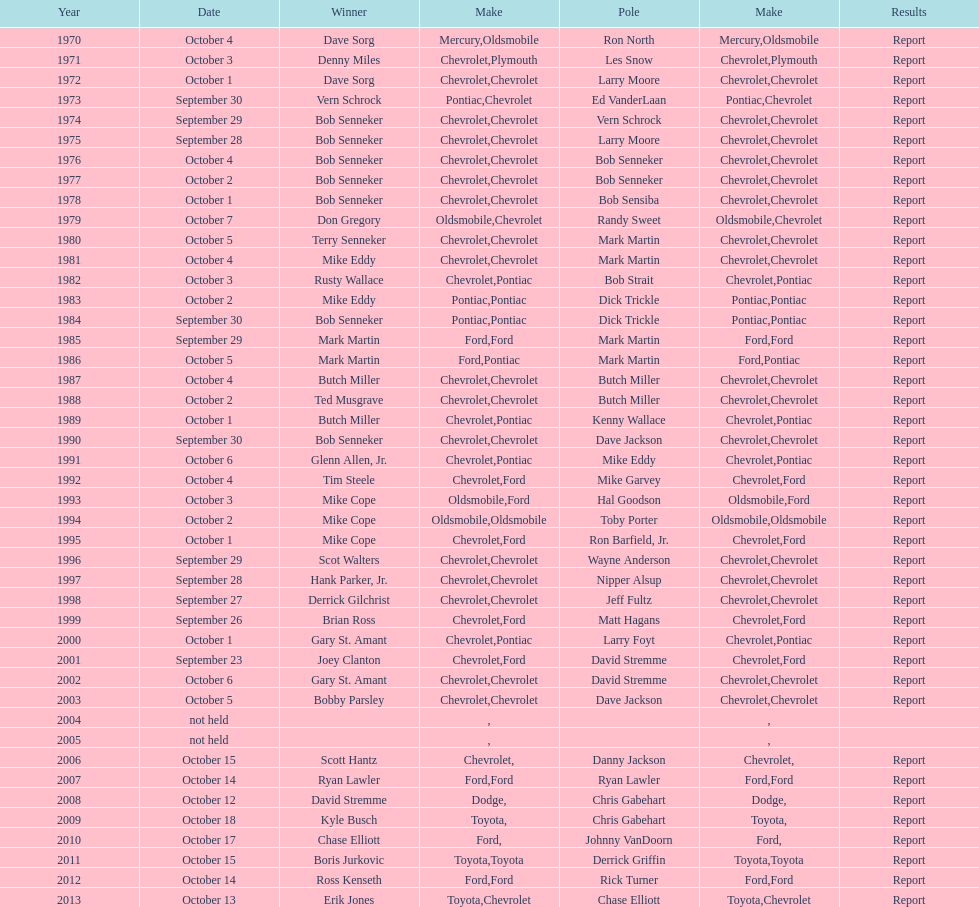Write the full table. {'header': ['Year', 'Date', 'Winner', 'Make', 'Pole', 'Make', 'Results'], 'rows': [['1970', 'October 4', 'Dave Sorg', 'Mercury', 'Ron North', 'Oldsmobile', 'Report'], ['1971', 'October 3', 'Denny Miles', 'Chevrolet', 'Les Snow', 'Plymouth', 'Report'], ['1972', 'October 1', 'Dave Sorg', 'Chevrolet', 'Larry Moore', 'Chevrolet', 'Report'], ['1973', 'September 30', 'Vern Schrock', 'Pontiac', 'Ed VanderLaan', 'Chevrolet', 'Report'], ['1974', 'September 29', 'Bob Senneker', 'Chevrolet', 'Vern Schrock', 'Chevrolet', 'Report'], ['1975', 'September 28', 'Bob Senneker', 'Chevrolet', 'Larry Moore', 'Chevrolet', 'Report'], ['1976', 'October 4', 'Bob Senneker', 'Chevrolet', 'Bob Senneker', 'Chevrolet', 'Report'], ['1977', 'October 2', 'Bob Senneker', 'Chevrolet', 'Bob Senneker', 'Chevrolet', 'Report'], ['1978', 'October 1', 'Bob Senneker', 'Chevrolet', 'Bob Sensiba', 'Chevrolet', 'Report'], ['1979', 'October 7', 'Don Gregory', 'Oldsmobile', 'Randy Sweet', 'Chevrolet', 'Report'], ['1980', 'October 5', 'Terry Senneker', 'Chevrolet', 'Mark Martin', 'Chevrolet', 'Report'], ['1981', 'October 4', 'Mike Eddy', 'Chevrolet', 'Mark Martin', 'Chevrolet', 'Report'], ['1982', 'October 3', 'Rusty Wallace', 'Chevrolet', 'Bob Strait', 'Pontiac', 'Report'], ['1983', 'October 2', 'Mike Eddy', 'Pontiac', 'Dick Trickle', 'Pontiac', 'Report'], ['1984', 'September 30', 'Bob Senneker', 'Pontiac', 'Dick Trickle', 'Pontiac', 'Report'], ['1985', 'September 29', 'Mark Martin', 'Ford', 'Mark Martin', 'Ford', 'Report'], ['1986', 'October 5', 'Mark Martin', 'Ford', 'Mark Martin', 'Pontiac', 'Report'], ['1987', 'October 4', 'Butch Miller', 'Chevrolet', 'Butch Miller', 'Chevrolet', 'Report'], ['1988', 'October 2', 'Ted Musgrave', 'Chevrolet', 'Butch Miller', 'Chevrolet', 'Report'], ['1989', 'October 1', 'Butch Miller', 'Chevrolet', 'Kenny Wallace', 'Pontiac', 'Report'], ['1990', 'September 30', 'Bob Senneker', 'Chevrolet', 'Dave Jackson', 'Chevrolet', 'Report'], ['1991', 'October 6', 'Glenn Allen, Jr.', 'Chevrolet', 'Mike Eddy', 'Pontiac', 'Report'], ['1992', 'October 4', 'Tim Steele', 'Chevrolet', 'Mike Garvey', 'Ford', 'Report'], ['1993', 'October 3', 'Mike Cope', 'Oldsmobile', 'Hal Goodson', 'Ford', 'Report'], ['1994', 'October 2', 'Mike Cope', 'Oldsmobile', 'Toby Porter', 'Oldsmobile', 'Report'], ['1995', 'October 1', 'Mike Cope', 'Chevrolet', 'Ron Barfield, Jr.', 'Ford', 'Report'], ['1996', 'September 29', 'Scot Walters', 'Chevrolet', 'Wayne Anderson', 'Chevrolet', 'Report'], ['1997', 'September 28', 'Hank Parker, Jr.', 'Chevrolet', 'Nipper Alsup', 'Chevrolet', 'Report'], ['1998', 'September 27', 'Derrick Gilchrist', 'Chevrolet', 'Jeff Fultz', 'Chevrolet', 'Report'], ['1999', 'September 26', 'Brian Ross', 'Chevrolet', 'Matt Hagans', 'Ford', 'Report'], ['2000', 'October 1', 'Gary St. Amant', 'Chevrolet', 'Larry Foyt', 'Pontiac', 'Report'], ['2001', 'September 23', 'Joey Clanton', 'Chevrolet', 'David Stremme', 'Ford', 'Report'], ['2002', 'October 6', 'Gary St. Amant', 'Chevrolet', 'David Stremme', 'Chevrolet', 'Report'], ['2003', 'October 5', 'Bobby Parsley', 'Chevrolet', 'Dave Jackson', 'Chevrolet', 'Report'], ['2004', 'not held', '', '', '', '', ''], ['2005', 'not held', '', '', '', '', ''], ['2006', 'October 15', 'Scott Hantz', 'Chevrolet', 'Danny Jackson', '', 'Report'], ['2007', 'October 14', 'Ryan Lawler', 'Ford', 'Ryan Lawler', 'Ford', 'Report'], ['2008', 'October 12', 'David Stremme', 'Dodge', 'Chris Gabehart', '', 'Report'], ['2009', 'October 18', 'Kyle Busch', 'Toyota', 'Chris Gabehart', '', 'Report'], ['2010', 'October 17', 'Chase Elliott', 'Ford', 'Johnny VanDoorn', '', 'Report'], ['2011', 'October 15', 'Boris Jurkovic', 'Toyota', 'Derrick Griffin', 'Toyota', 'Report'], ['2012', 'October 14', 'Ross Kenseth', 'Ford', 'Rick Turner', 'Ford', 'Report'], ['2013', 'October 13', 'Erik Jones', 'Toyota', 'Chase Elliott', 'Chevrolet', 'Report']]} Who has the longest winning streak on the given list? Bob Senneker. 